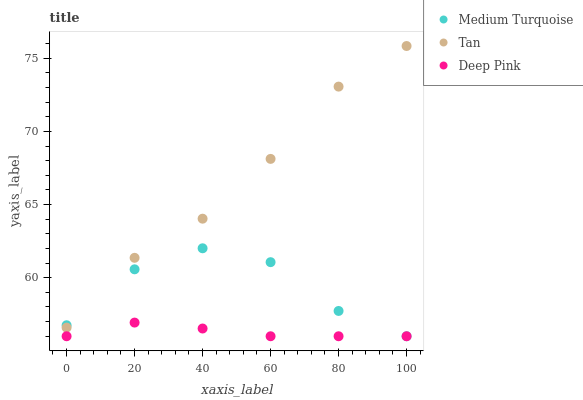Does Deep Pink have the minimum area under the curve?
Answer yes or no. Yes. Does Tan have the maximum area under the curve?
Answer yes or no. Yes. Does Medium Turquoise have the minimum area under the curve?
Answer yes or no. No. Does Medium Turquoise have the maximum area under the curve?
Answer yes or no. No. Is Deep Pink the smoothest?
Answer yes or no. Yes. Is Medium Turquoise the roughest?
Answer yes or no. Yes. Is Medium Turquoise the smoothest?
Answer yes or no. No. Is Deep Pink the roughest?
Answer yes or no. No. Does Deep Pink have the lowest value?
Answer yes or no. Yes. Does Tan have the highest value?
Answer yes or no. Yes. Does Medium Turquoise have the highest value?
Answer yes or no. No. Is Deep Pink less than Tan?
Answer yes or no. Yes. Is Tan greater than Deep Pink?
Answer yes or no. Yes. Does Deep Pink intersect Medium Turquoise?
Answer yes or no. Yes. Is Deep Pink less than Medium Turquoise?
Answer yes or no. No. Is Deep Pink greater than Medium Turquoise?
Answer yes or no. No. Does Deep Pink intersect Tan?
Answer yes or no. No. 